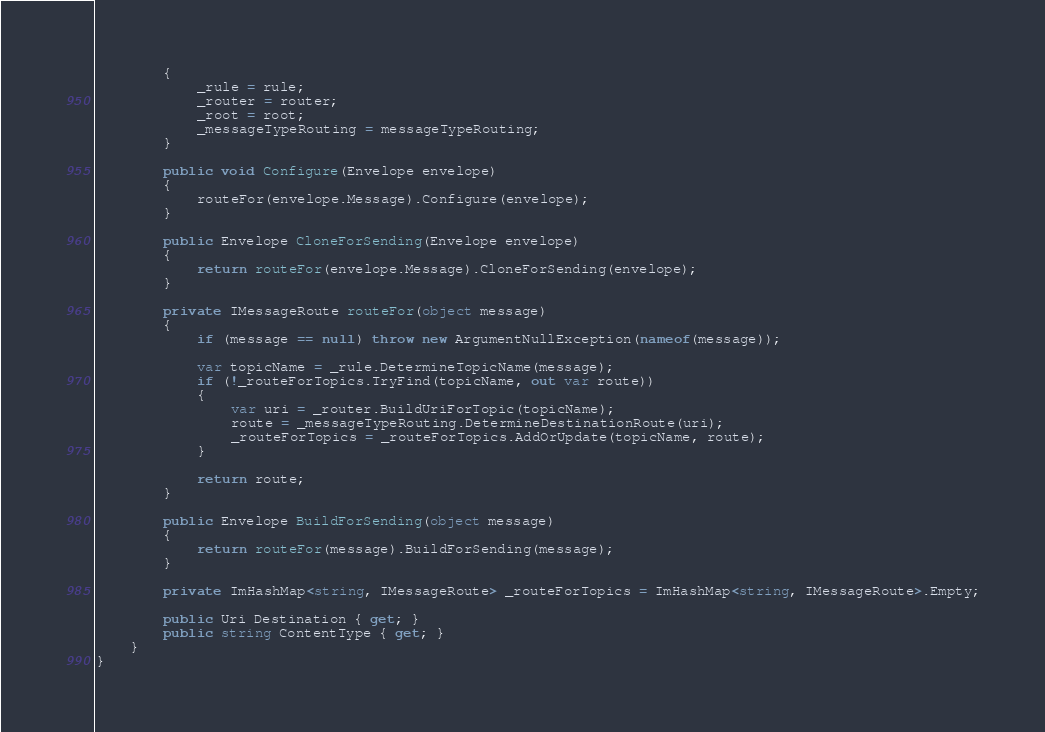Convert code to text. <code><loc_0><loc_0><loc_500><loc_500><_C#_>        {
            _rule = rule;
            _router = router;
            _root = root;
            _messageTypeRouting = messageTypeRouting;
        }

        public void Configure(Envelope envelope)
        {
            routeFor(envelope.Message).Configure(envelope);
        }

        public Envelope CloneForSending(Envelope envelope)
        {
            return routeFor(envelope.Message).CloneForSending(envelope);
        }

        private IMessageRoute routeFor(object message)
        {
            if (message == null) throw new ArgumentNullException(nameof(message));

            var topicName = _rule.DetermineTopicName(message);
            if (!_routeForTopics.TryFind(topicName, out var route))
            {
                var uri = _router.BuildUriForTopic(topicName);
                route = _messageTypeRouting.DetermineDestinationRoute(uri);
                _routeForTopics = _routeForTopics.AddOrUpdate(topicName, route);
            }

            return route;
        }

        public Envelope BuildForSending(object message)
        {
            return routeFor(message).BuildForSending(message);
        }

        private ImHashMap<string, IMessageRoute> _routeForTopics = ImHashMap<string, IMessageRoute>.Empty;

        public Uri Destination { get; }
        public string ContentType { get; }
    }
}
</code> 